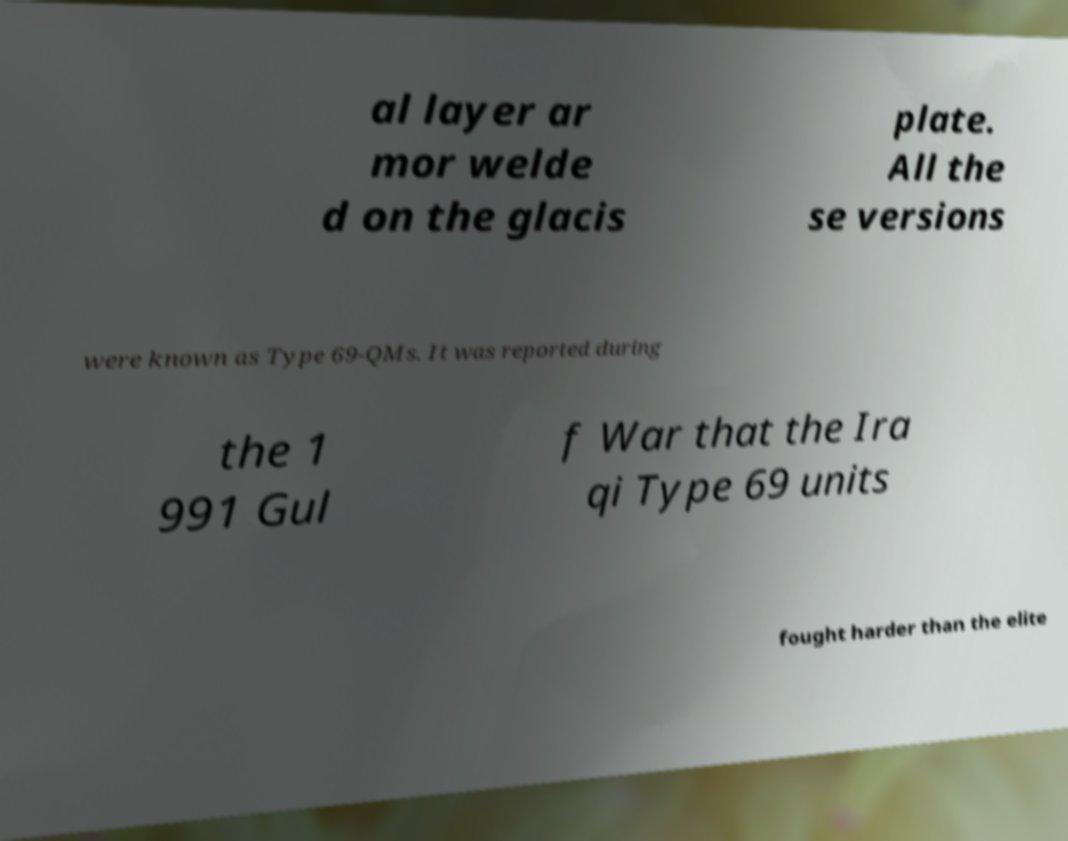Please identify and transcribe the text found in this image. al layer ar mor welde d on the glacis plate. All the se versions were known as Type 69-QMs. It was reported during the 1 991 Gul f War that the Ira qi Type 69 units fought harder than the elite 